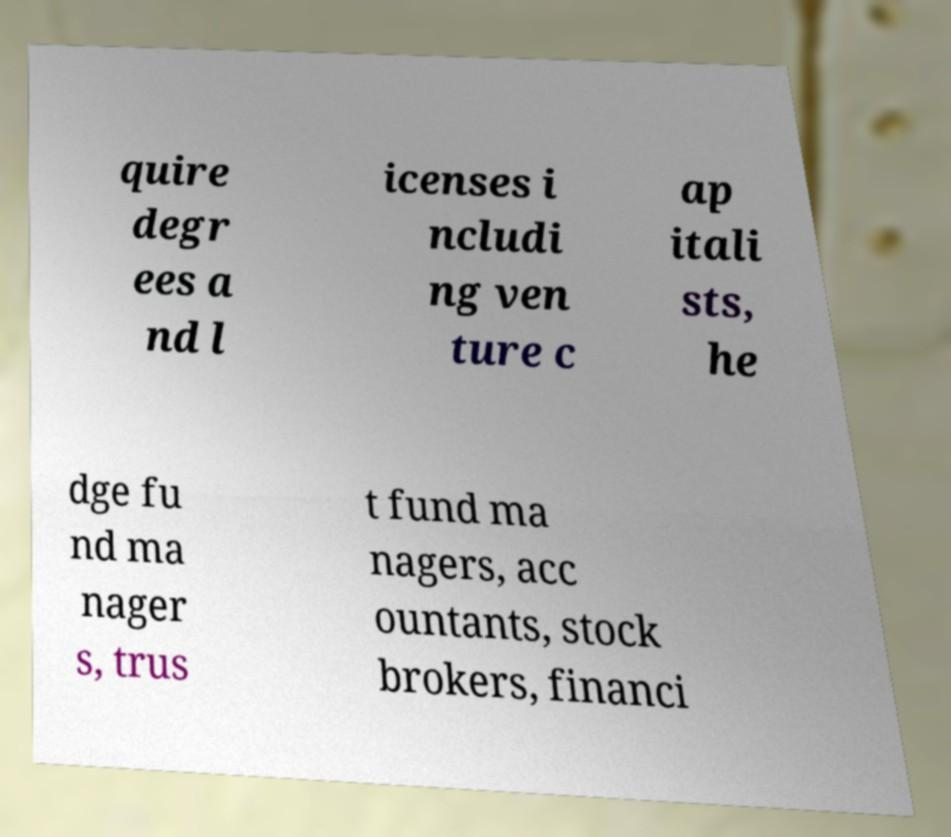Can you read and provide the text displayed in the image?This photo seems to have some interesting text. Can you extract and type it out for me? quire degr ees a nd l icenses i ncludi ng ven ture c ap itali sts, he dge fu nd ma nager s, trus t fund ma nagers, acc ountants, stock brokers, financi 